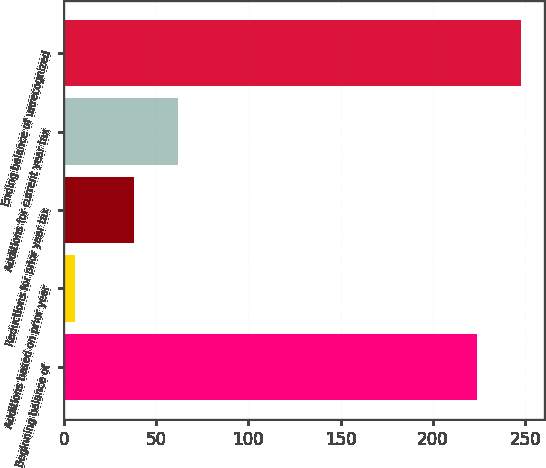Convert chart. <chart><loc_0><loc_0><loc_500><loc_500><bar_chart><fcel>Beginning balance of<fcel>Additions based on prior year<fcel>Reductions for prior year tax<fcel>Additions for current year tax<fcel>Ending balance of unrecognized<nl><fcel>224<fcel>6<fcel>38<fcel>61.8<fcel>247.8<nl></chart> 